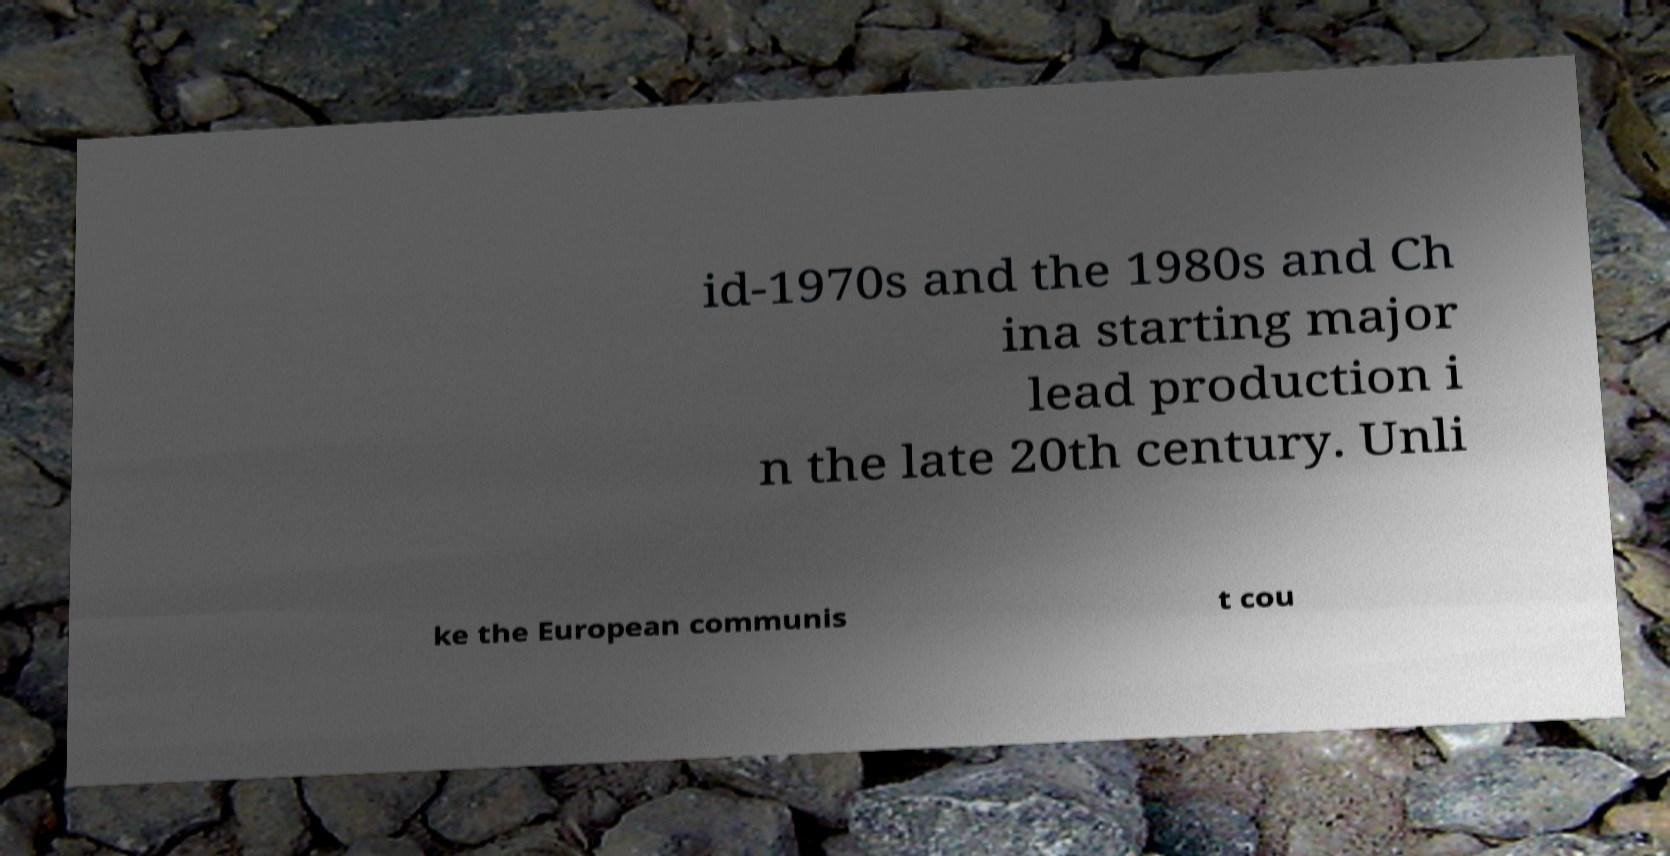I need the written content from this picture converted into text. Can you do that? id-1970s and the 1980s and Ch ina starting major lead production i n the late 20th century. Unli ke the European communis t cou 